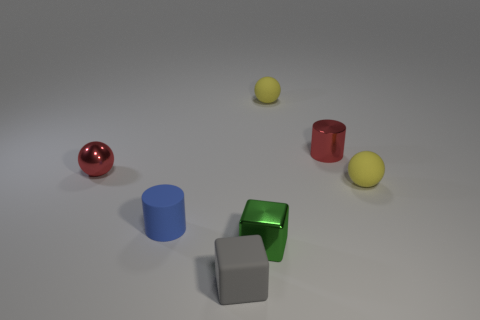Imagine these objects are part of a game. What kind of game could it be, and how would it be played? One can imagine these objects being part of an educational game for young children designed to teach them about colors and shapes. Players could be asked to match similar shapes or colors, or alternatively, construct a structure using the objects following specific rules or patterns. 